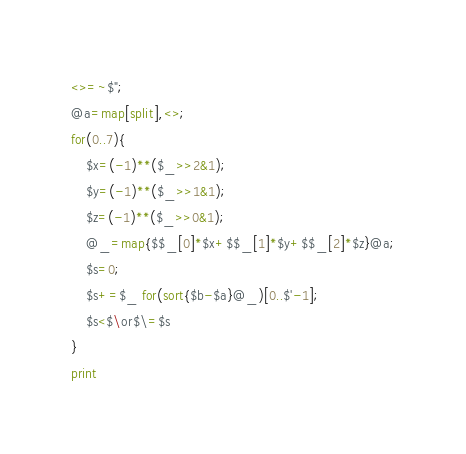Convert code to text. <code><loc_0><loc_0><loc_500><loc_500><_Perl_><>=~$";
@a=map[split],<>;
for(0..7){
	$x=(-1)**($_>>2&1);
	$y=(-1)**($_>>1&1);
	$z=(-1)**($_>>0&1);
	@_=map{$$_[0]*$x+$$_[1]*$y+$$_[2]*$z}@a;
	$s=0;
	$s+=$_ for(sort{$b-$a}@_)[0..$'-1];
	$s<$\or$\=$s
}
print
</code> 